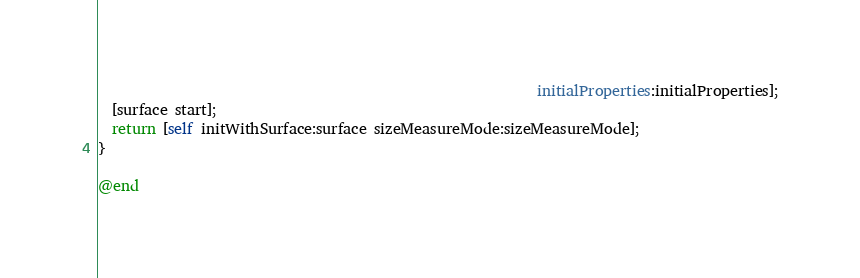Convert code to text. <code><loc_0><loc_0><loc_500><loc_500><_ObjectiveC_>                                                             initialProperties:initialProperties];
  [surface start];
  return [self initWithSurface:surface sizeMeasureMode:sizeMeasureMode];
}

@end
</code> 